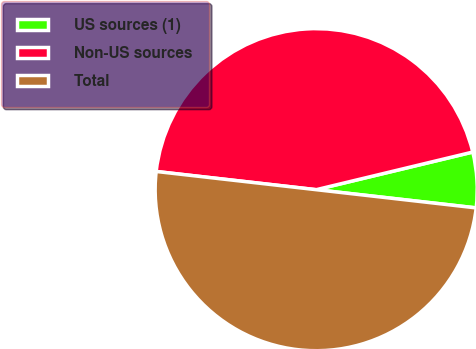<chart> <loc_0><loc_0><loc_500><loc_500><pie_chart><fcel>US sources (1)<fcel>Non-US sources<fcel>Total<nl><fcel>5.56%<fcel>44.44%<fcel>50.0%<nl></chart> 